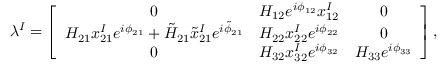Convert formula to latex. <formula><loc_0><loc_0><loc_500><loc_500>\lambda ^ { I } = \left [ \begin{array} { c c c } { 0 } & { { H _ { 1 2 } e ^ { i \phi _ { 1 2 } } x _ { 1 2 } ^ { I } } } & { 0 } \\ { { H _ { 2 1 } x _ { 2 1 } ^ { I } e ^ { i \phi _ { 2 1 } } + \tilde { H } _ { 2 1 } \tilde { x } _ { 2 1 } ^ { I } e ^ { i \tilde { \phi } _ { 2 1 } } } } & { { H _ { 2 2 } x _ { 2 2 } ^ { I } e ^ { i \phi _ { 2 2 } } } } & { 0 } \\ { 0 } & { { H _ { 3 2 } x _ { 3 2 } ^ { I } e ^ { i \phi _ { 3 2 } } } } & { { H _ { 3 3 } e ^ { i \phi _ { 3 3 } } } } \end{array} \right ] ,</formula> 